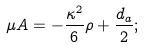Convert formula to latex. <formula><loc_0><loc_0><loc_500><loc_500>\mu A = - \frac { \kappa ^ { 2 } } { 6 } \rho + \frac { d _ { a } } { 2 } ;</formula> 